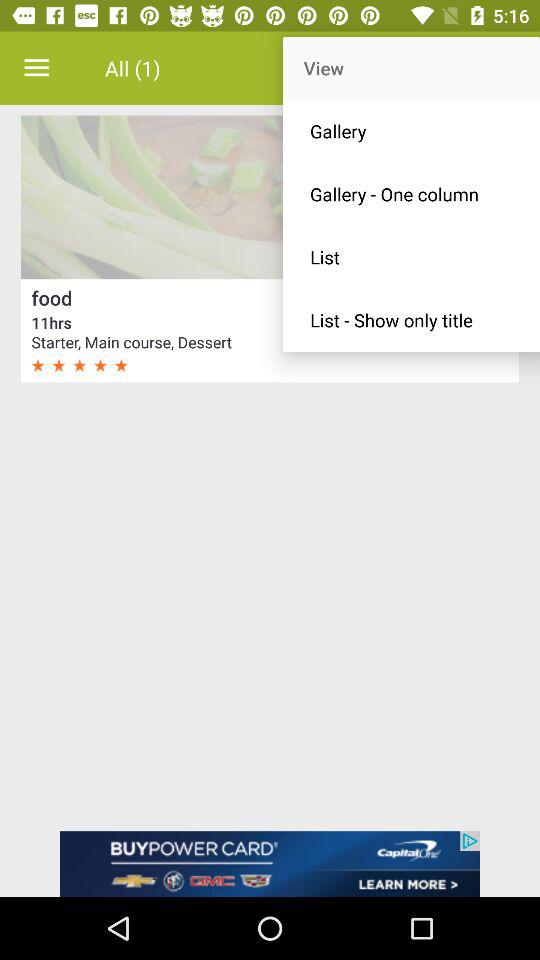How many unread notifications are there in all? There is 1 unread notification. 